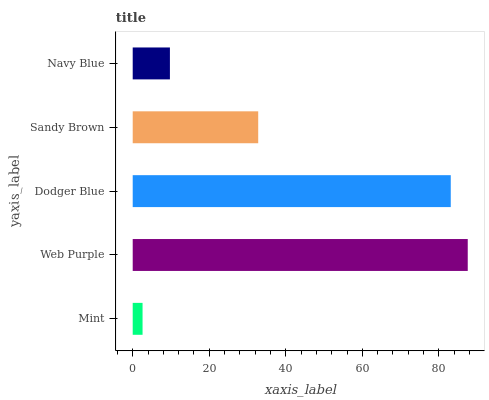Is Mint the minimum?
Answer yes or no. Yes. Is Web Purple the maximum?
Answer yes or no. Yes. Is Dodger Blue the minimum?
Answer yes or no. No. Is Dodger Blue the maximum?
Answer yes or no. No. Is Web Purple greater than Dodger Blue?
Answer yes or no. Yes. Is Dodger Blue less than Web Purple?
Answer yes or no. Yes. Is Dodger Blue greater than Web Purple?
Answer yes or no. No. Is Web Purple less than Dodger Blue?
Answer yes or no. No. Is Sandy Brown the high median?
Answer yes or no. Yes. Is Sandy Brown the low median?
Answer yes or no. Yes. Is Mint the high median?
Answer yes or no. No. Is Dodger Blue the low median?
Answer yes or no. No. 